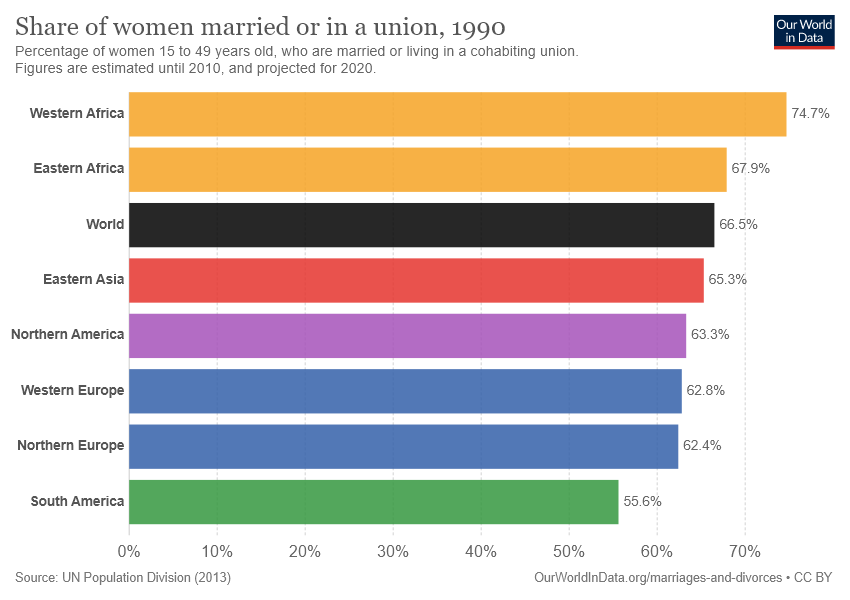Mention a couple of crucial points in this snapshot. The average percentage of two blue bars and two yellow bars separately is [62.6, 71.3]. South America is the region presented by the green bar. 